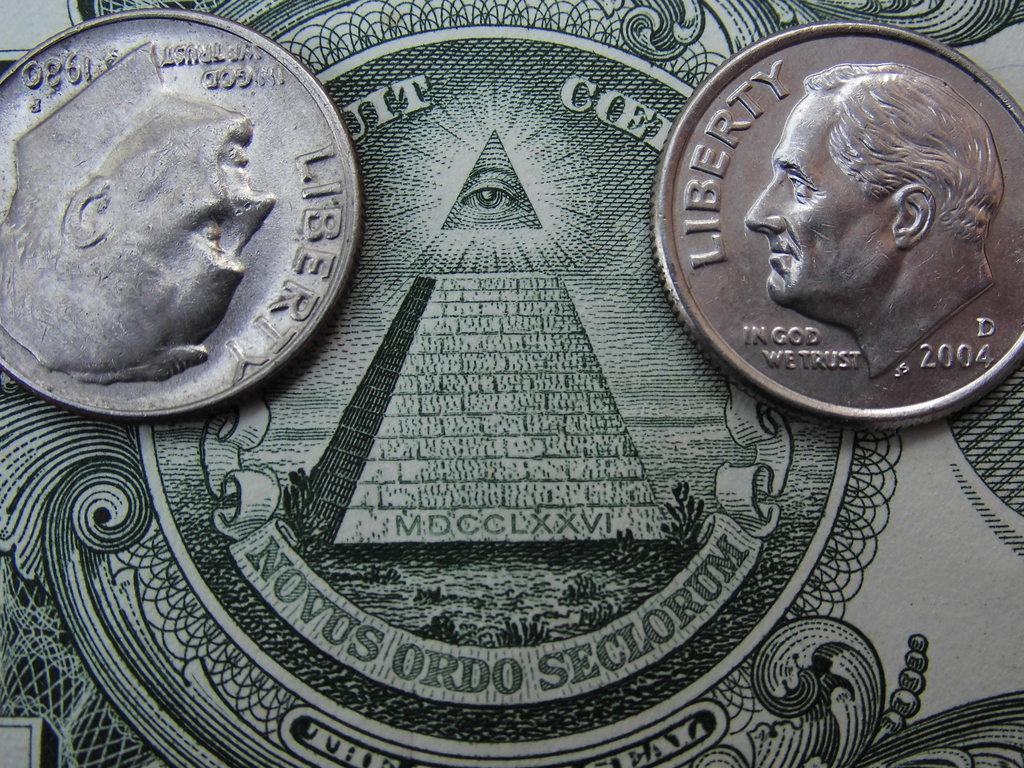<image>
Share a concise interpretation of the image provided. two Liberty silver coins on a bill with MDCCLXXVI on it 